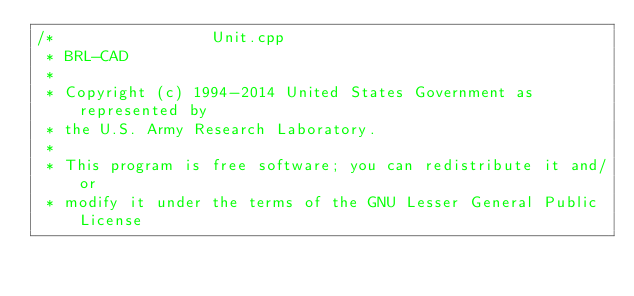<code> <loc_0><loc_0><loc_500><loc_500><_C++_>/*                 Unit.cpp
 * BRL-CAD
 *
 * Copyright (c) 1994-2014 United States Government as represented by
 * the U.S. Army Research Laboratory.
 *
 * This program is free software; you can redistribute it and/or
 * modify it under the terms of the GNU Lesser General Public License</code> 